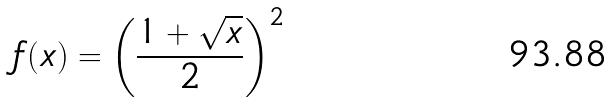<formula> <loc_0><loc_0><loc_500><loc_500>f ( x ) = \left ( \frac { 1 + \sqrt { x } } { 2 } \right ) ^ { 2 }</formula> 